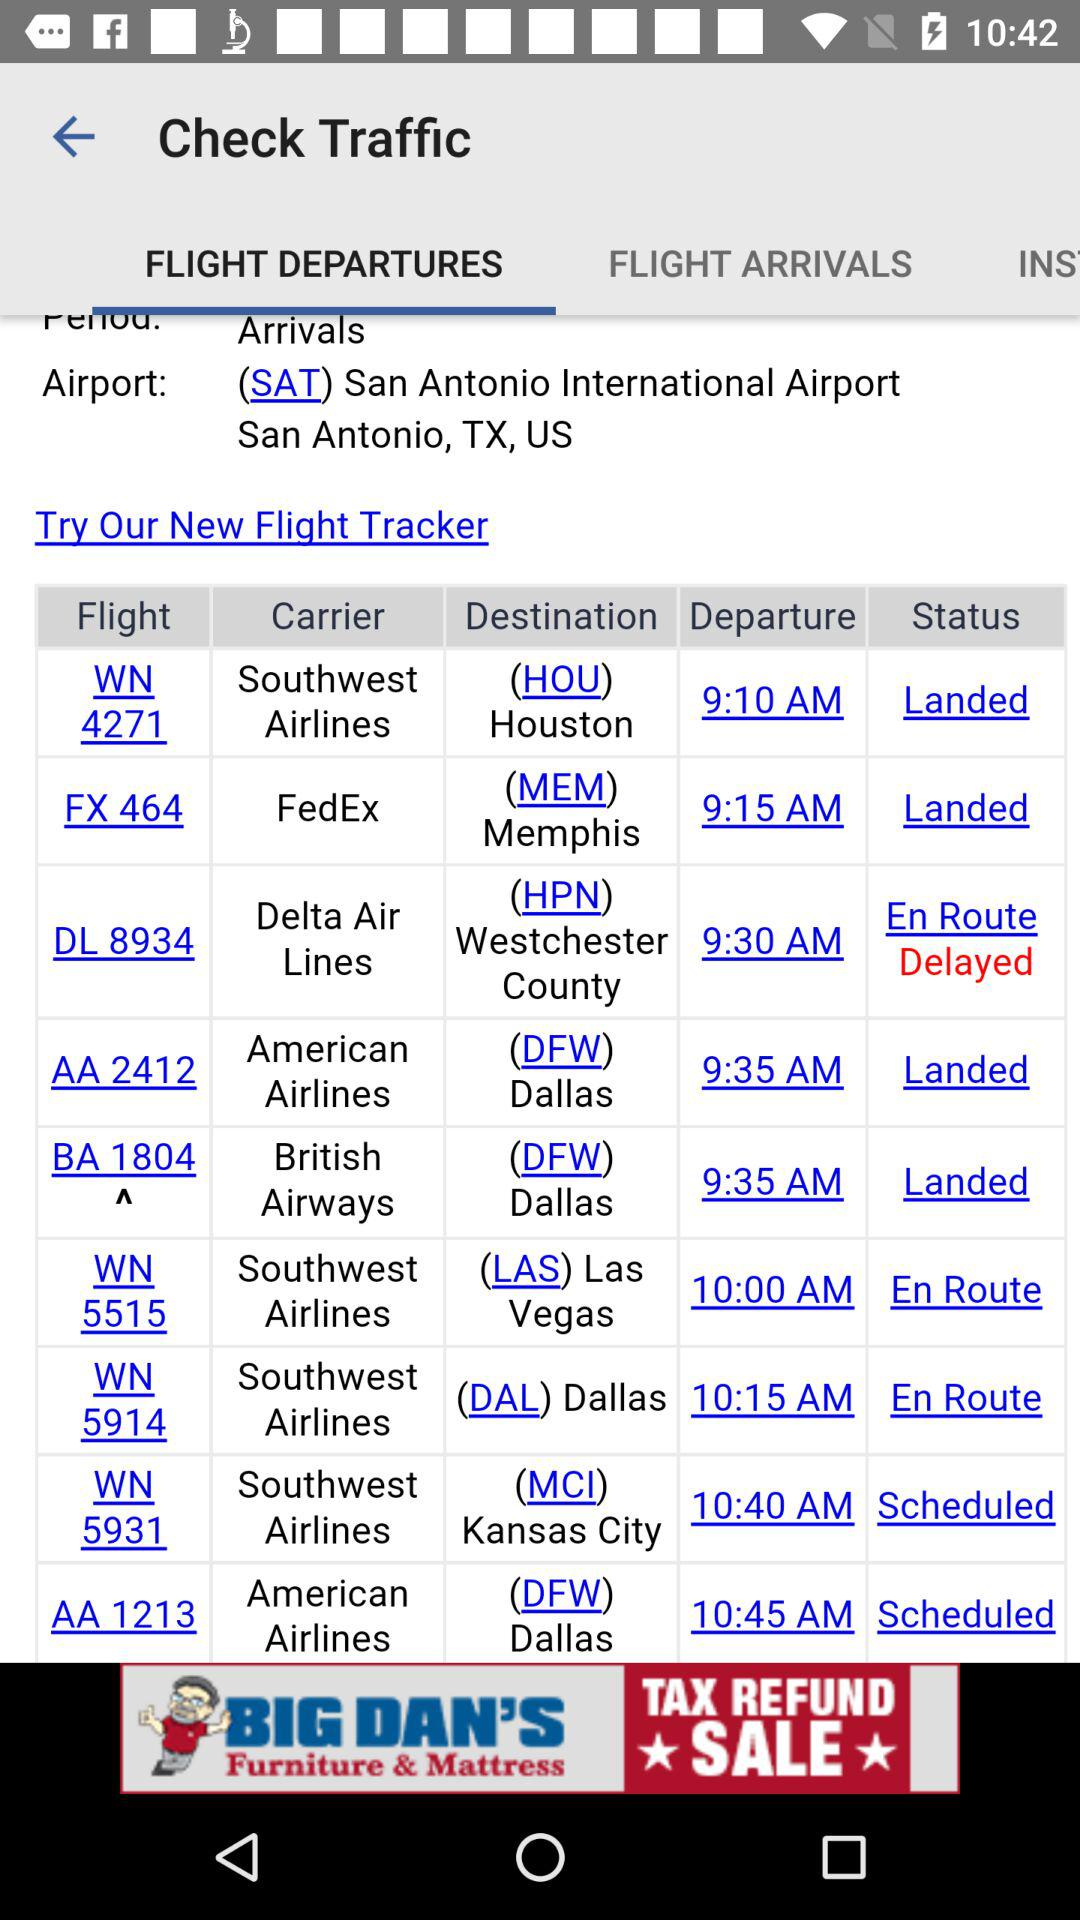What is the status of the British Airways flight? The status of the British Airways flight is "Landed". 